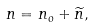Convert formula to latex. <formula><loc_0><loc_0><loc_500><loc_500>n = n _ { o } + \widetilde { n } ,</formula> 